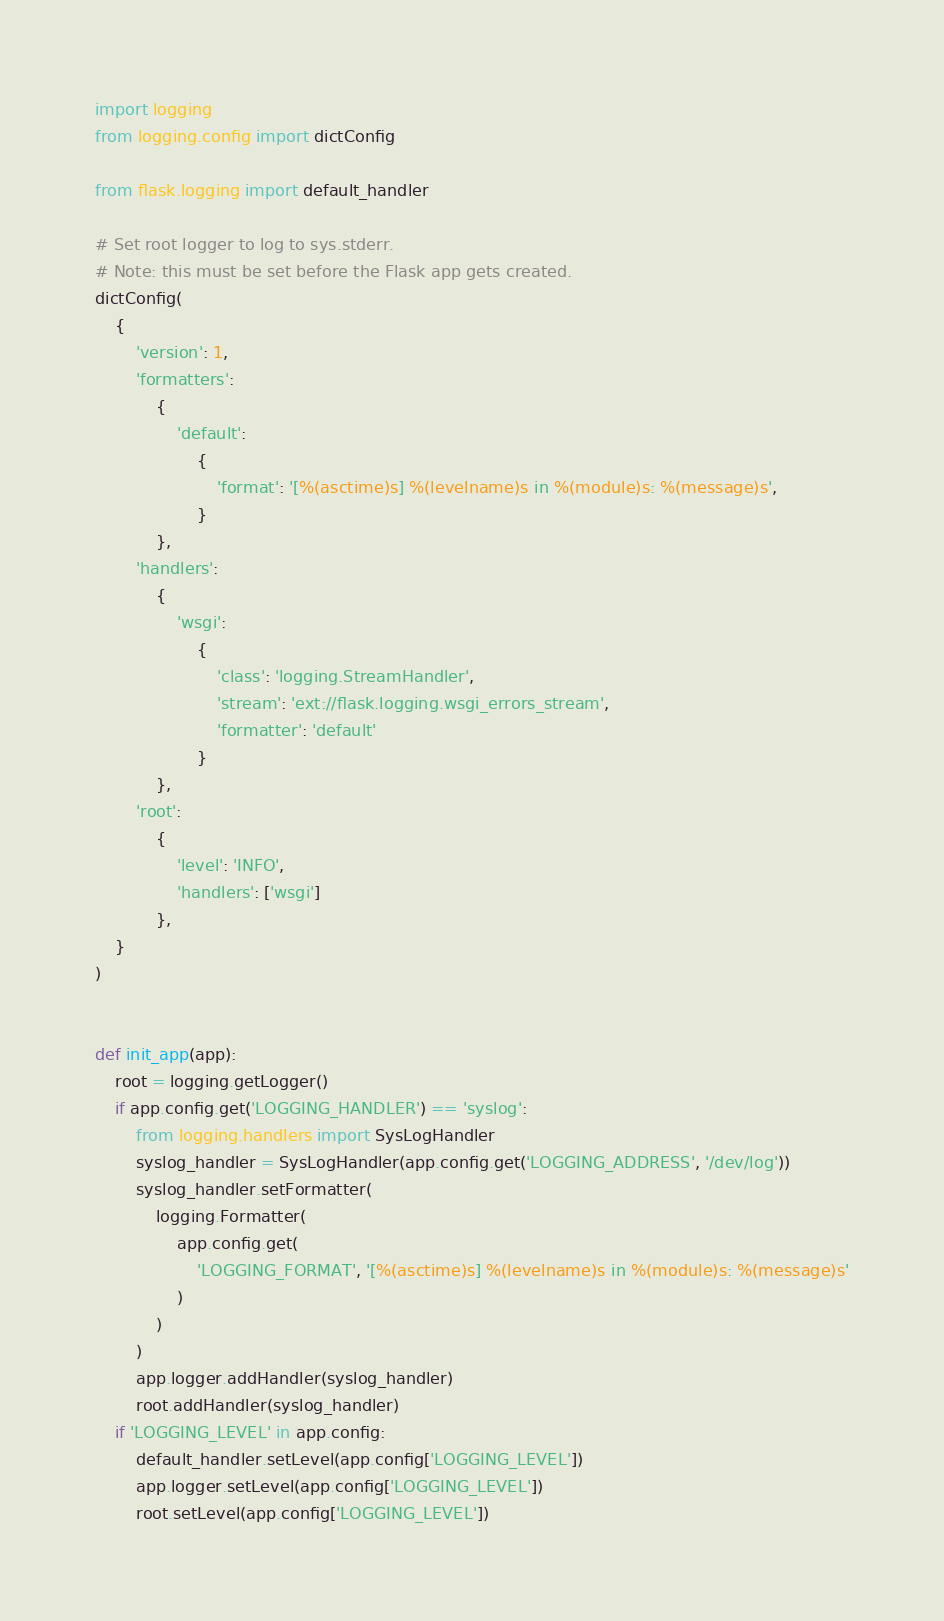Convert code to text. <code><loc_0><loc_0><loc_500><loc_500><_Python_>import logging
from logging.config import dictConfig

from flask.logging import default_handler

# Set root logger to log to sys.stderr.
# Note: this must be set before the Flask app gets created.
dictConfig(
    {
        'version': 1,
        'formatters':
            {
                'default':
                    {
                        'format': '[%(asctime)s] %(levelname)s in %(module)s: %(message)s',
                    }
            },
        'handlers':
            {
                'wsgi':
                    {
                        'class': 'logging.StreamHandler',
                        'stream': 'ext://flask.logging.wsgi_errors_stream',
                        'formatter': 'default'
                    }
            },
        'root':
            {
                'level': 'INFO',
                'handlers': ['wsgi']
            },
    }
)


def init_app(app):
    root = logging.getLogger()
    if app.config.get('LOGGING_HANDLER') == 'syslog':
        from logging.handlers import SysLogHandler
        syslog_handler = SysLogHandler(app.config.get('LOGGING_ADDRESS', '/dev/log'))
        syslog_handler.setFormatter(
            logging.Formatter(
                app.config.get(
                    'LOGGING_FORMAT', '[%(asctime)s] %(levelname)s in %(module)s: %(message)s'
                )
            )
        )
        app.logger.addHandler(syslog_handler)
        root.addHandler(syslog_handler)
    if 'LOGGING_LEVEL' in app.config:
        default_handler.setLevel(app.config['LOGGING_LEVEL'])
        app.logger.setLevel(app.config['LOGGING_LEVEL'])
        root.setLevel(app.config['LOGGING_LEVEL'])
</code> 